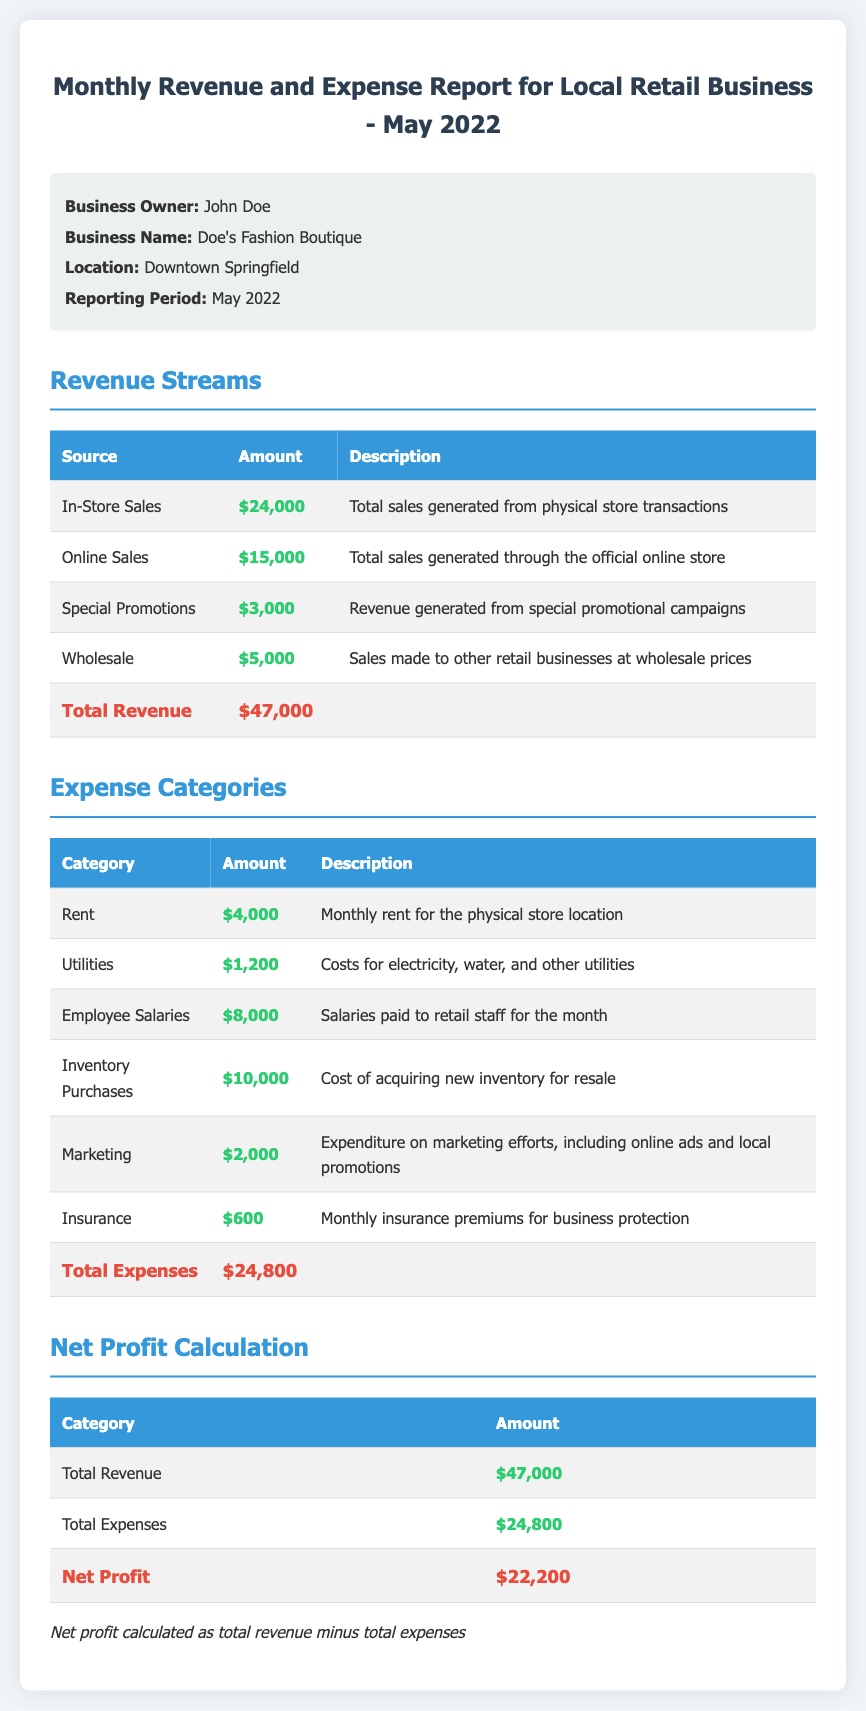what is the total revenue? The total revenue is presented at the end of the Revenue Streams section and calculated by summing all revenue sources, which totals $47,000.
Answer: $47,000 what is the total expense amount? The total expenses are displayed at the end of the Expense Categories section and calculated by summing all expenses, which equals $24,800.
Answer: $24,800 who is the business owner? The business owner's name is mentioned at the beginning of the document as John Doe.
Answer: John Doe which location does the business operate in? The document specifies the location of the business as Downtown Springfield.
Answer: Downtown Springfield what was the amount for employee salaries? The amount for employee salaries is listed in the Expense Categories table as $8,000.
Answer: $8,000 how much revenue was generated from online sales? The document indicates that the revenue generated from online sales is $15,000.
Answer: $15,000 what is the net profit calculated? The net profit is computed as the difference between total revenue and total expenses, which results in $22,200.
Answer: $22,200 which category incurred the highest expense? The highest expense category listed in the document is Inventory Purchases with an amount of $10,000.
Answer: Inventory Purchases what percentage of total revenue does the rent expense represent? The rent expense of $4,000 is calculated as a percentage of total revenue ($47,000), giving approximately 8.51%.
Answer: 8.51% 